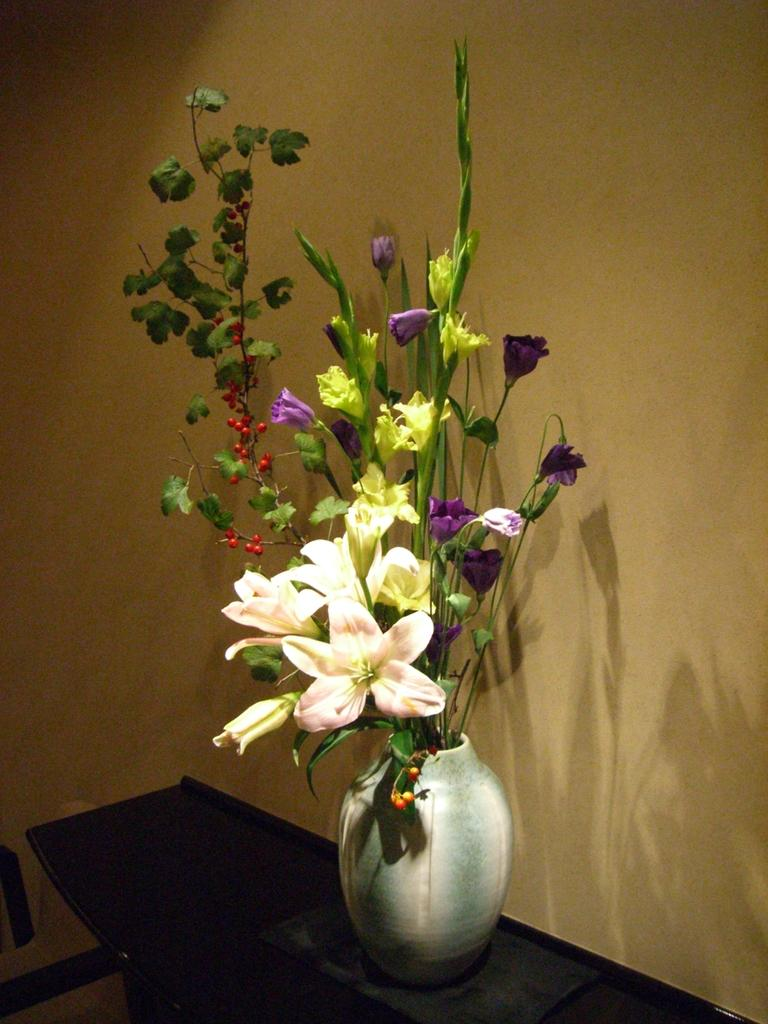What is present on the wall in the image? There is a wall in the image, but no specific details about its contents are provided. What is located near the wall? There is a table near the wall. What can be seen on the table? There is a flower vase on the table. What type of cactus is growing on the wall in the image? There is no cactus present on the wall in the image. What piece of art is hanging on the wall in the image? The provided facts do not mention any art on the wall in the image. 